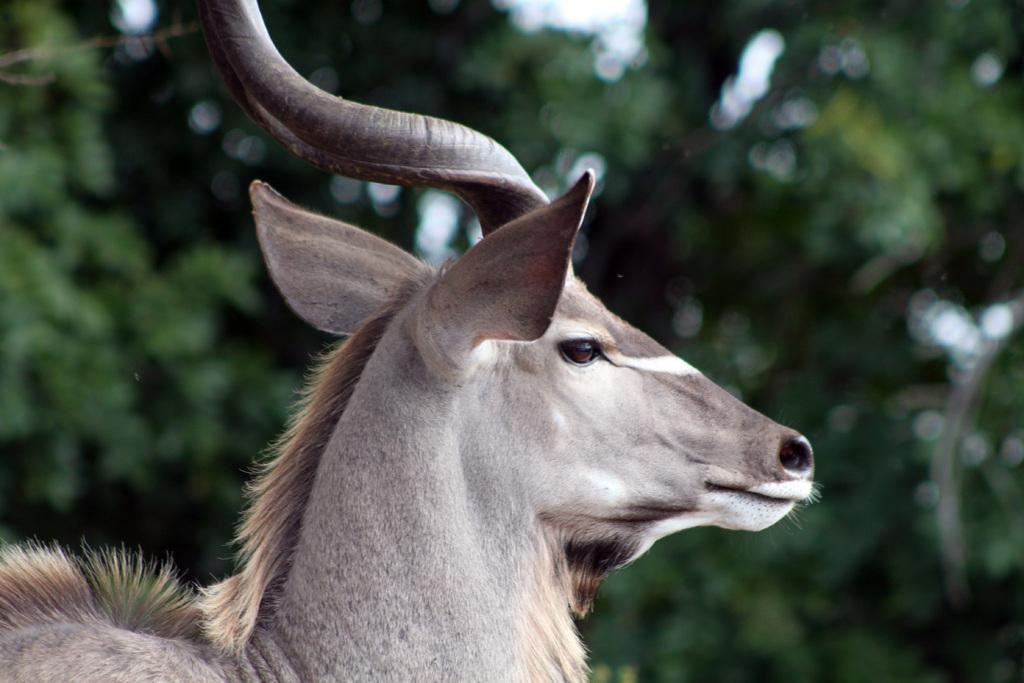What type of animal is in the image? There is a kudu in the image. What can be seen in the background of the image? There are trees visible in the background of the image. What is the purpose of the tank in the image? There is no tank present in the image; it features a kudu and trees in the background. 